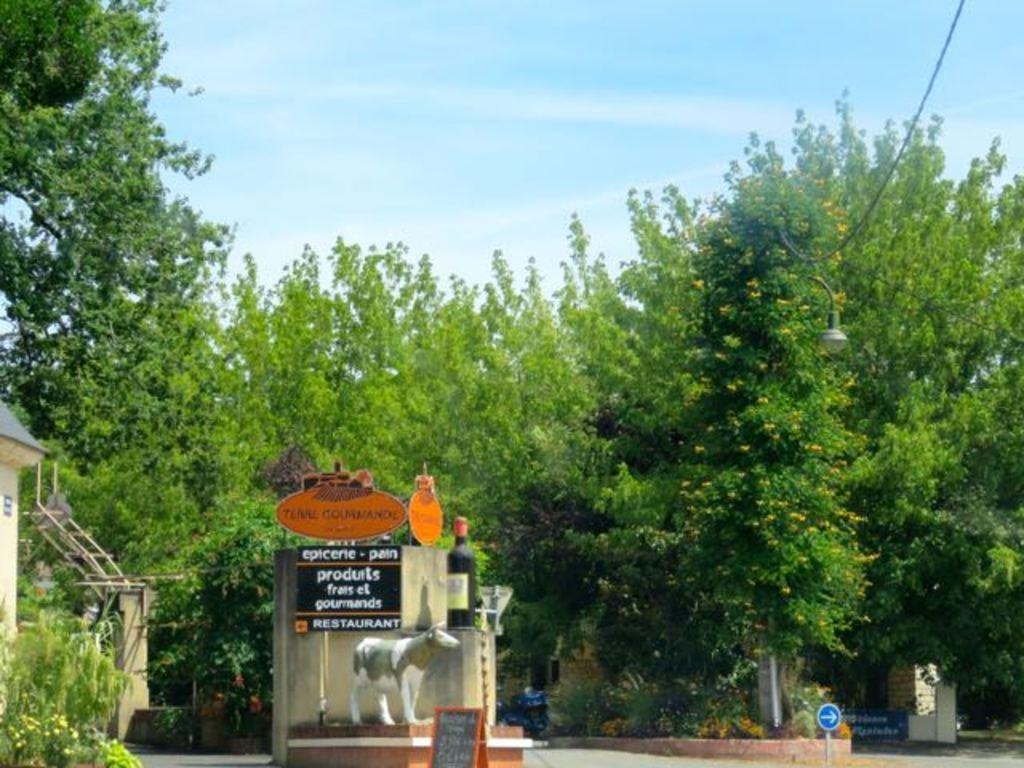What type of structures can be seen in the image? There are buildings in the image. What objects are present in the image besides the buildings? There are boards and a statue visible in the image. What can be seen in the background of the image? Trees are visible in the background of the image. What is visible at the top of the image? The sky is visible at the top of the image. What type of pencil can be seen in the image? There is no pencil present in the image. What substance is being transported by the railway in the image? There is no railway present in the image. 